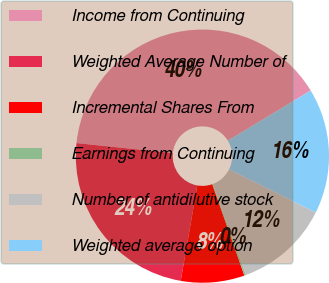Convert chart to OTSL. <chart><loc_0><loc_0><loc_500><loc_500><pie_chart><fcel>Income from Continuing<fcel>Weighted Average Number of<fcel>Incremental Shares From<fcel>Earnings from Continuing<fcel>Number of antidilutive stock<fcel>Weighted average option<nl><fcel>39.69%<fcel>23.9%<fcel>8.12%<fcel>0.22%<fcel>12.06%<fcel>16.01%<nl></chart> 